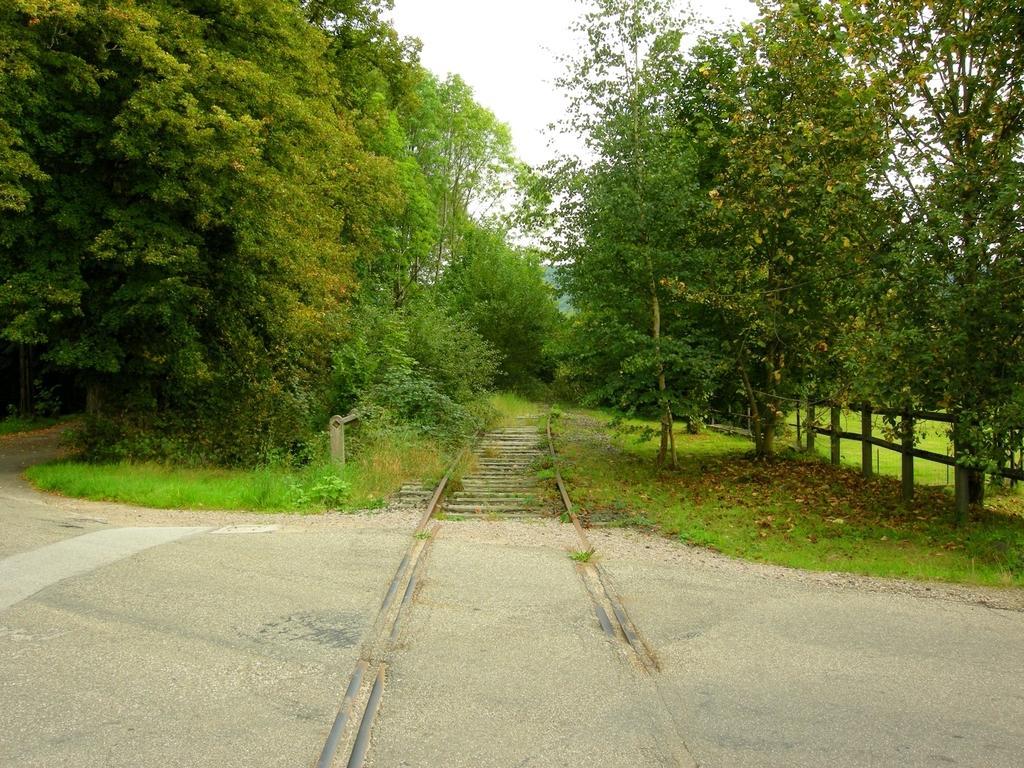Can you describe this image briefly? It is the railway track, this is the road. These are the green color trees in the middle of an image. At the top it is the sky. 